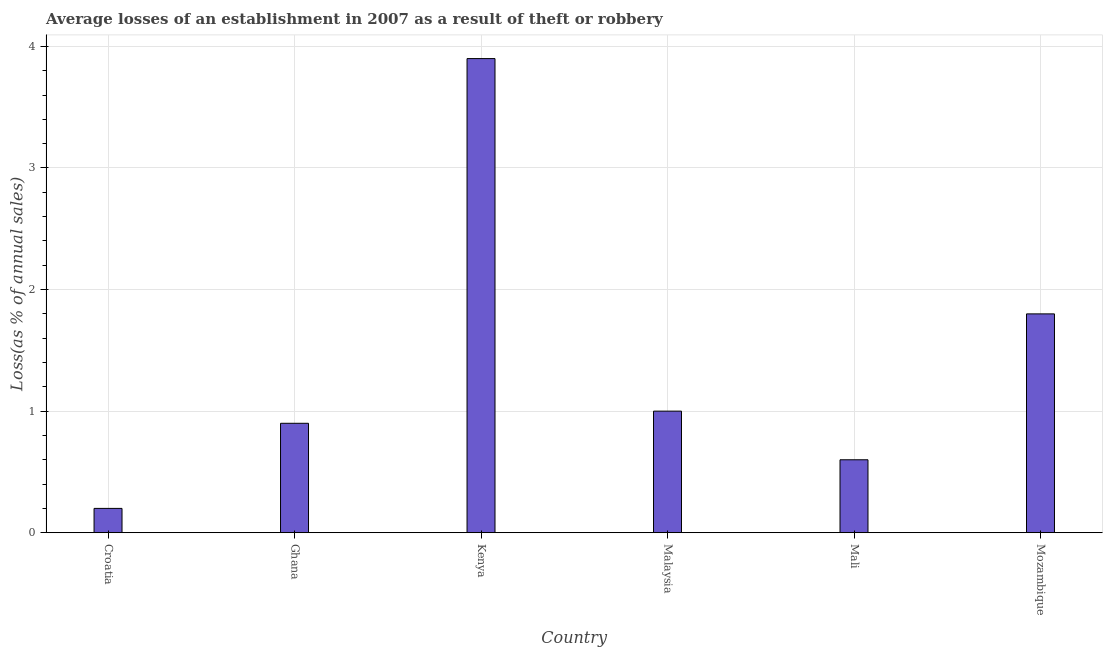Does the graph contain any zero values?
Give a very brief answer. No. What is the title of the graph?
Provide a short and direct response. Average losses of an establishment in 2007 as a result of theft or robbery. What is the label or title of the Y-axis?
Your response must be concise. Loss(as % of annual sales). In which country was the losses due to theft maximum?
Make the answer very short. Kenya. In which country was the losses due to theft minimum?
Give a very brief answer. Croatia. What is the average losses due to theft per country?
Your answer should be compact. 1.4. What is the median losses due to theft?
Offer a very short reply. 0.95. In how many countries, is the losses due to theft greater than 3.4 %?
Your answer should be compact. 1. What is the ratio of the losses due to theft in Ghana to that in Mali?
Make the answer very short. 1.5. Is the difference between the losses due to theft in Croatia and Mozambique greater than the difference between any two countries?
Keep it short and to the point. No. In how many countries, is the losses due to theft greater than the average losses due to theft taken over all countries?
Your answer should be very brief. 2. How many bars are there?
Make the answer very short. 6. Are all the bars in the graph horizontal?
Provide a succinct answer. No. How many countries are there in the graph?
Make the answer very short. 6. What is the Loss(as % of annual sales) in Ghana?
Make the answer very short. 0.9. What is the Loss(as % of annual sales) of Malaysia?
Your response must be concise. 1. What is the Loss(as % of annual sales) in Mozambique?
Provide a short and direct response. 1.8. What is the difference between the Loss(as % of annual sales) in Croatia and Mali?
Your answer should be compact. -0.4. What is the difference between the Loss(as % of annual sales) in Ghana and Kenya?
Keep it short and to the point. -3. What is the difference between the Loss(as % of annual sales) in Ghana and Mozambique?
Your answer should be compact. -0.9. What is the difference between the Loss(as % of annual sales) in Kenya and Mozambique?
Ensure brevity in your answer.  2.1. What is the difference between the Loss(as % of annual sales) in Malaysia and Mali?
Offer a terse response. 0.4. What is the difference between the Loss(as % of annual sales) in Mali and Mozambique?
Ensure brevity in your answer.  -1.2. What is the ratio of the Loss(as % of annual sales) in Croatia to that in Ghana?
Give a very brief answer. 0.22. What is the ratio of the Loss(as % of annual sales) in Croatia to that in Kenya?
Offer a terse response. 0.05. What is the ratio of the Loss(as % of annual sales) in Croatia to that in Mali?
Offer a terse response. 0.33. What is the ratio of the Loss(as % of annual sales) in Croatia to that in Mozambique?
Offer a terse response. 0.11. What is the ratio of the Loss(as % of annual sales) in Ghana to that in Kenya?
Your answer should be very brief. 0.23. What is the ratio of the Loss(as % of annual sales) in Kenya to that in Mali?
Make the answer very short. 6.5. What is the ratio of the Loss(as % of annual sales) in Kenya to that in Mozambique?
Ensure brevity in your answer.  2.17. What is the ratio of the Loss(as % of annual sales) in Malaysia to that in Mali?
Provide a succinct answer. 1.67. What is the ratio of the Loss(as % of annual sales) in Malaysia to that in Mozambique?
Your answer should be compact. 0.56. What is the ratio of the Loss(as % of annual sales) in Mali to that in Mozambique?
Keep it short and to the point. 0.33. 